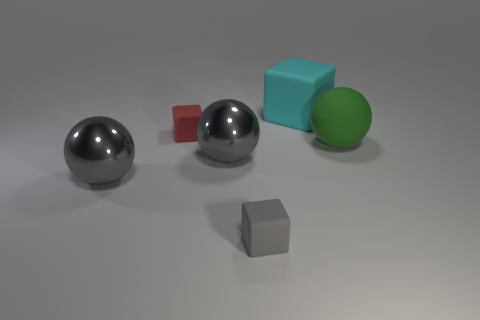Can you determine which object is closest to the light source based on the image? Based on the shadows and the highlights on the objects, the large sphere on the left seems closest to the light source as it has the brightest highlight, indicating it’s receiving the most direct light. 